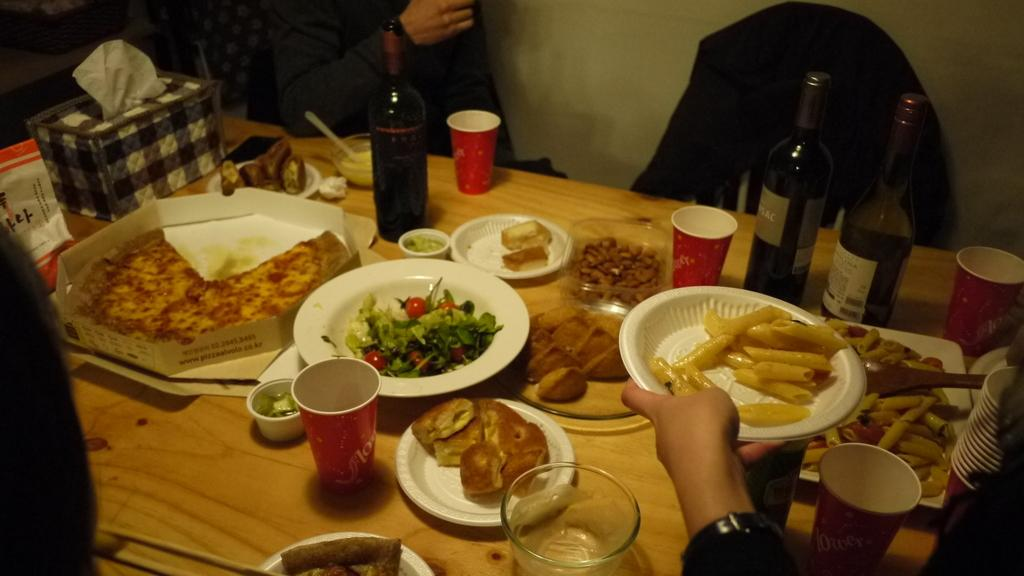What types of food or dishes can be seen in the image? There are different types of dishes in the image. What beverage is associated with the dishes in the image? Champagne bottles are present in the image. What type of dessert is visible in the image? There are cookies in the image. Where are the dishes and beverages located? The items are on a table. Who might be enjoying the food and drinks in the image? There are people around the table. Can you see a pear on the table in the image? There is no pear visible on the table in the image. Is there a kitten playing with the cookies in the image? There is no kitten present in the image. 